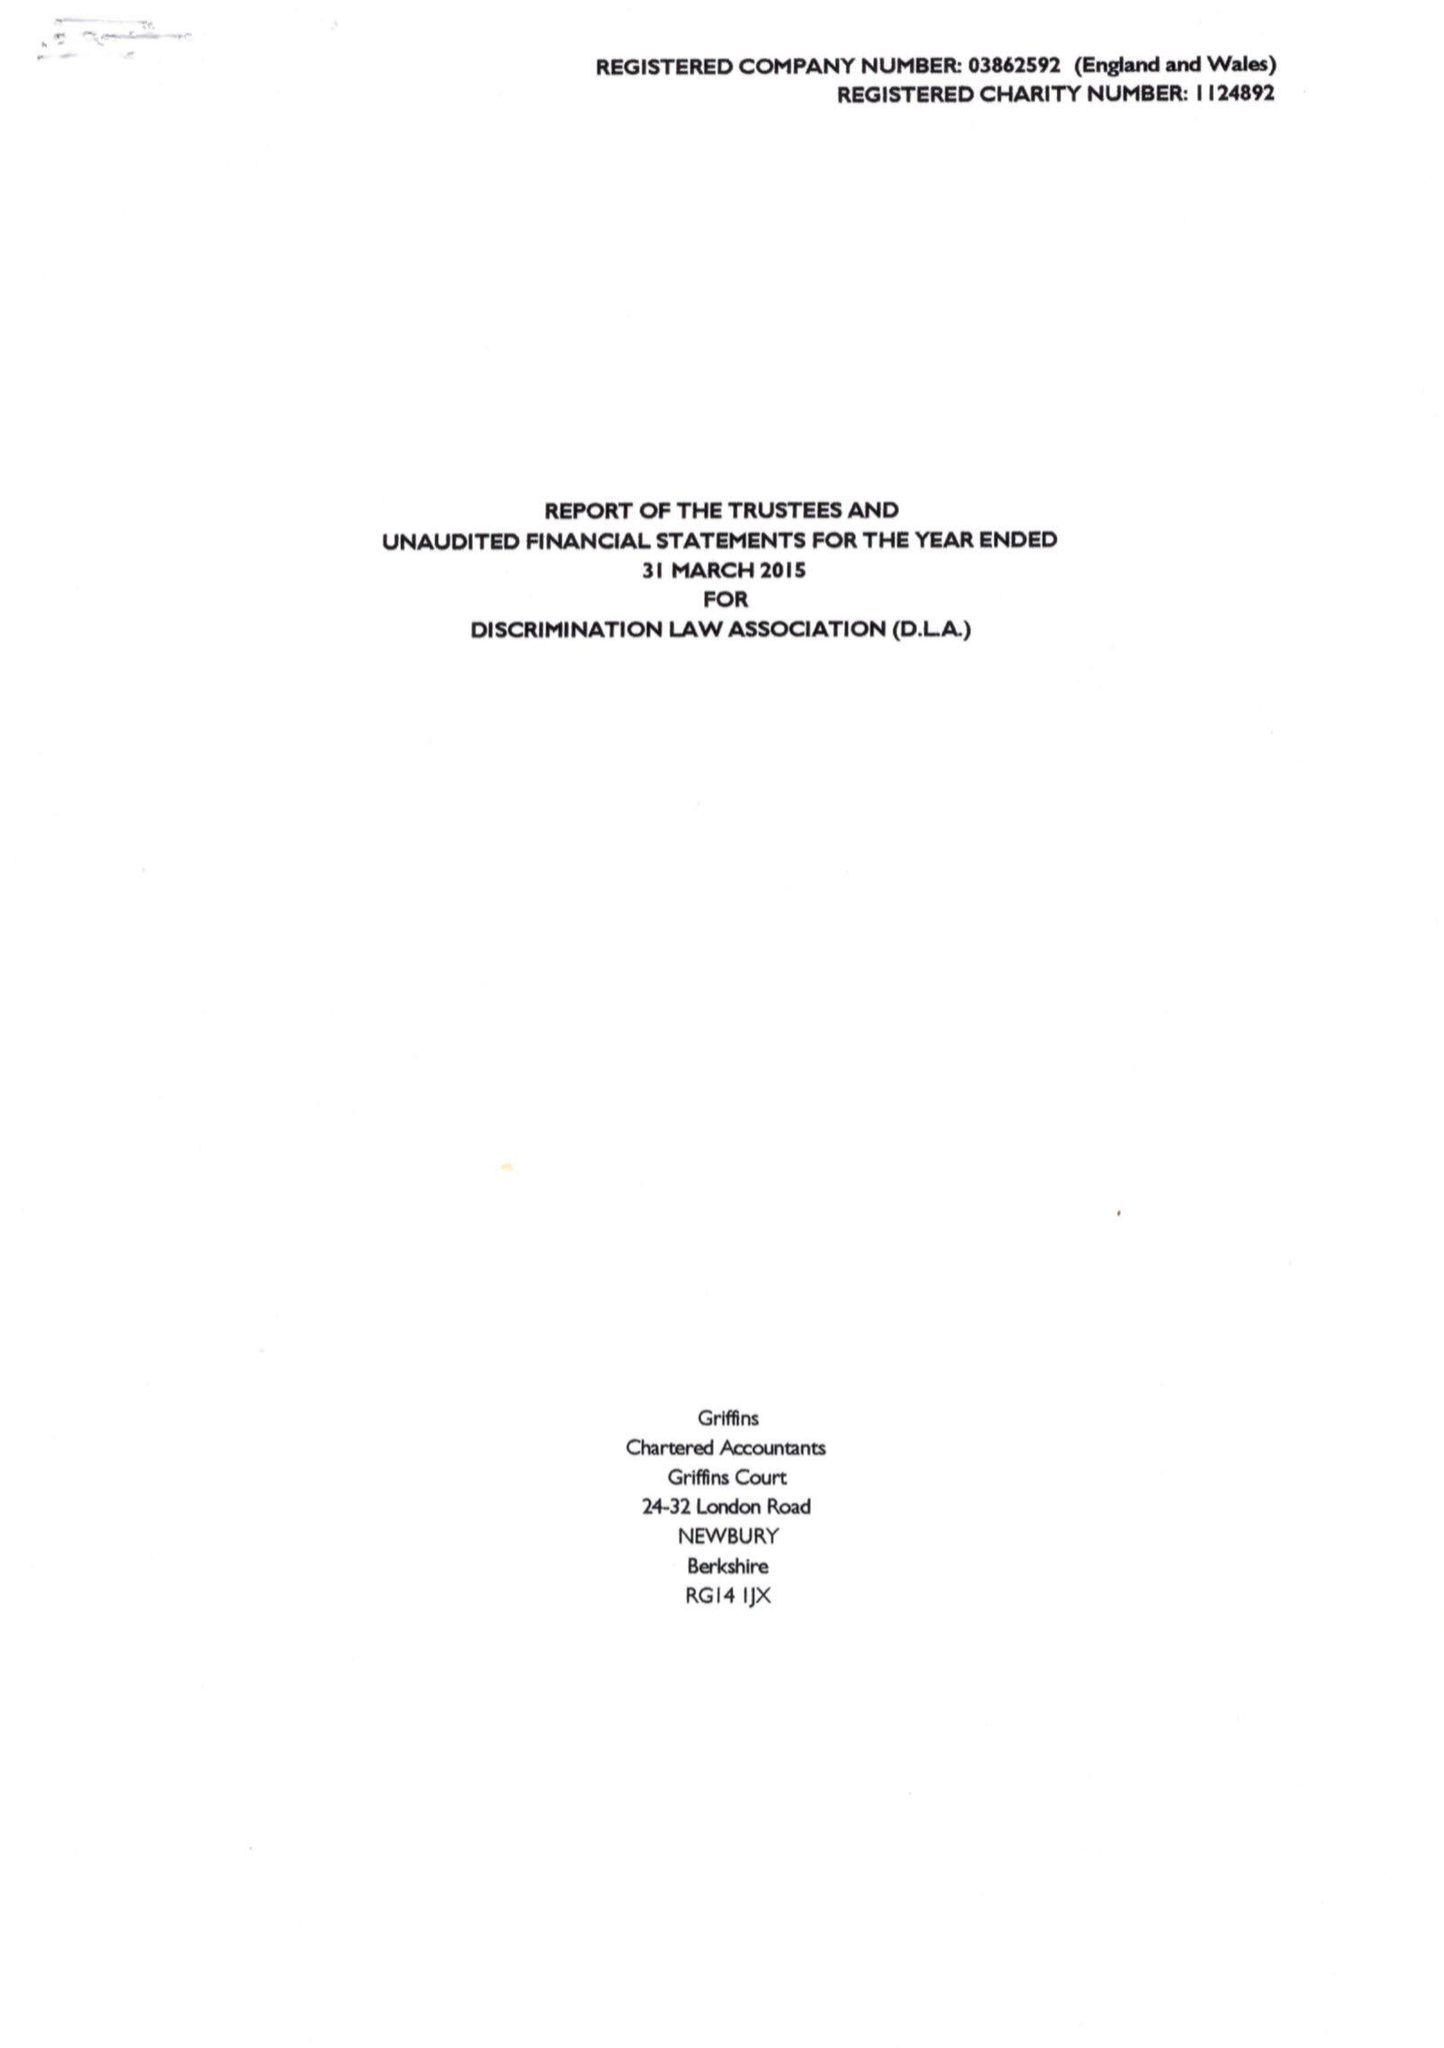What is the value for the charity_name?
Answer the question using a single word or phrase. Discrimination Law Association 